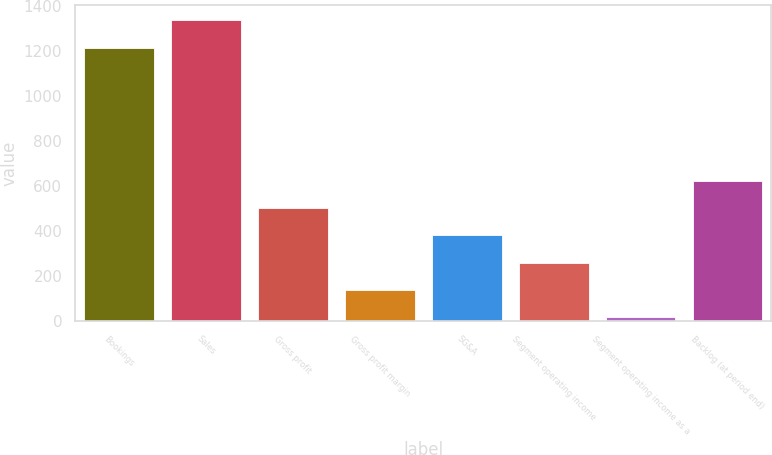Convert chart to OTSL. <chart><loc_0><loc_0><loc_500><loc_500><bar_chart><fcel>Bookings<fcel>Sales<fcel>Gross profit<fcel>Gross profit margin<fcel>SG&A<fcel>Segment operating income<fcel>Segment operating income as a<fcel>Backlog (at period end)<nl><fcel>1216.8<fcel>1338.53<fcel>503.32<fcel>138.13<fcel>381.59<fcel>259.86<fcel>16.4<fcel>625.05<nl></chart> 